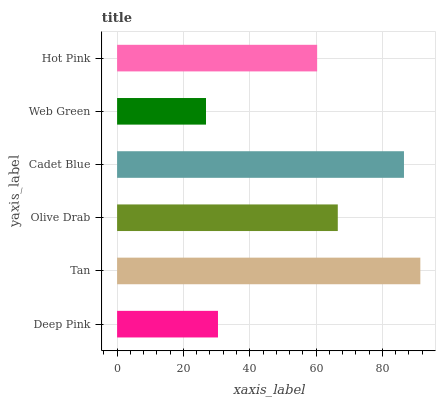Is Web Green the minimum?
Answer yes or no. Yes. Is Tan the maximum?
Answer yes or no. Yes. Is Olive Drab the minimum?
Answer yes or no. No. Is Olive Drab the maximum?
Answer yes or no. No. Is Tan greater than Olive Drab?
Answer yes or no. Yes. Is Olive Drab less than Tan?
Answer yes or no. Yes. Is Olive Drab greater than Tan?
Answer yes or no. No. Is Tan less than Olive Drab?
Answer yes or no. No. Is Olive Drab the high median?
Answer yes or no. Yes. Is Hot Pink the low median?
Answer yes or no. Yes. Is Hot Pink the high median?
Answer yes or no. No. Is Olive Drab the low median?
Answer yes or no. No. 